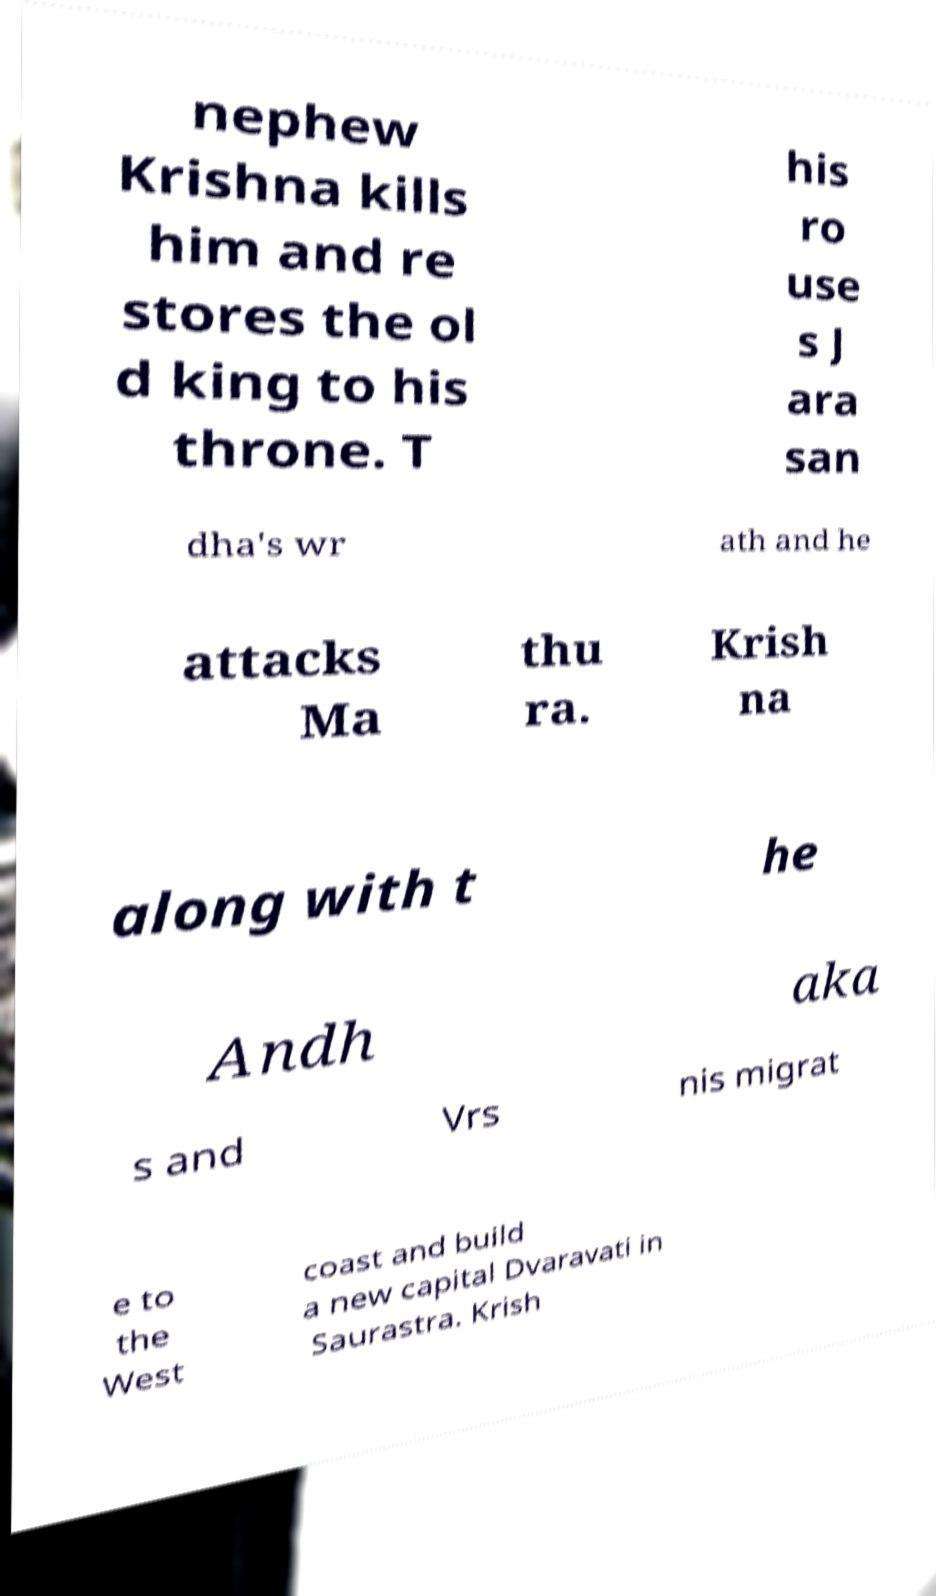There's text embedded in this image that I need extracted. Can you transcribe it verbatim? nephew Krishna kills him and re stores the ol d king to his throne. T his ro use s J ara san dha's wr ath and he attacks Ma thu ra. Krish na along with t he Andh aka s and Vrs nis migrat e to the West coast and build a new capital Dvaravati in Saurastra. Krish 